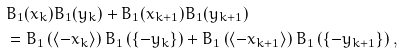Convert formula to latex. <formula><loc_0><loc_0><loc_500><loc_500>& B _ { 1 } ( x _ { k } ) B _ { 1 } ( y _ { k } ) + B _ { 1 } ( x _ { k + 1 } ) B _ { 1 } ( y _ { k + 1 } ) \\ & = B _ { 1 } \left ( \langle - x _ { k } \rangle \right ) B _ { 1 } \left ( \{ - y _ { k } \} \right ) + B _ { 1 } \left ( \langle - x _ { k + 1 } \rangle \right ) B _ { 1 } \left ( \{ - y _ { k + 1 } \} \right ) ,</formula> 